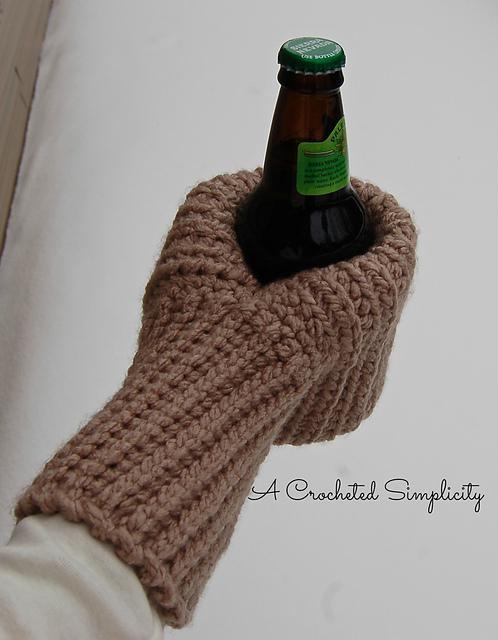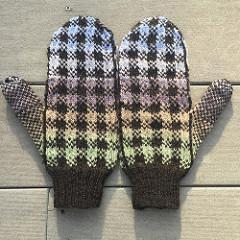The first image is the image on the left, the second image is the image on the right. Given the left and right images, does the statement "The left and right image contains the same number of mittens with at least one set green." hold true? Answer yes or no. No. 